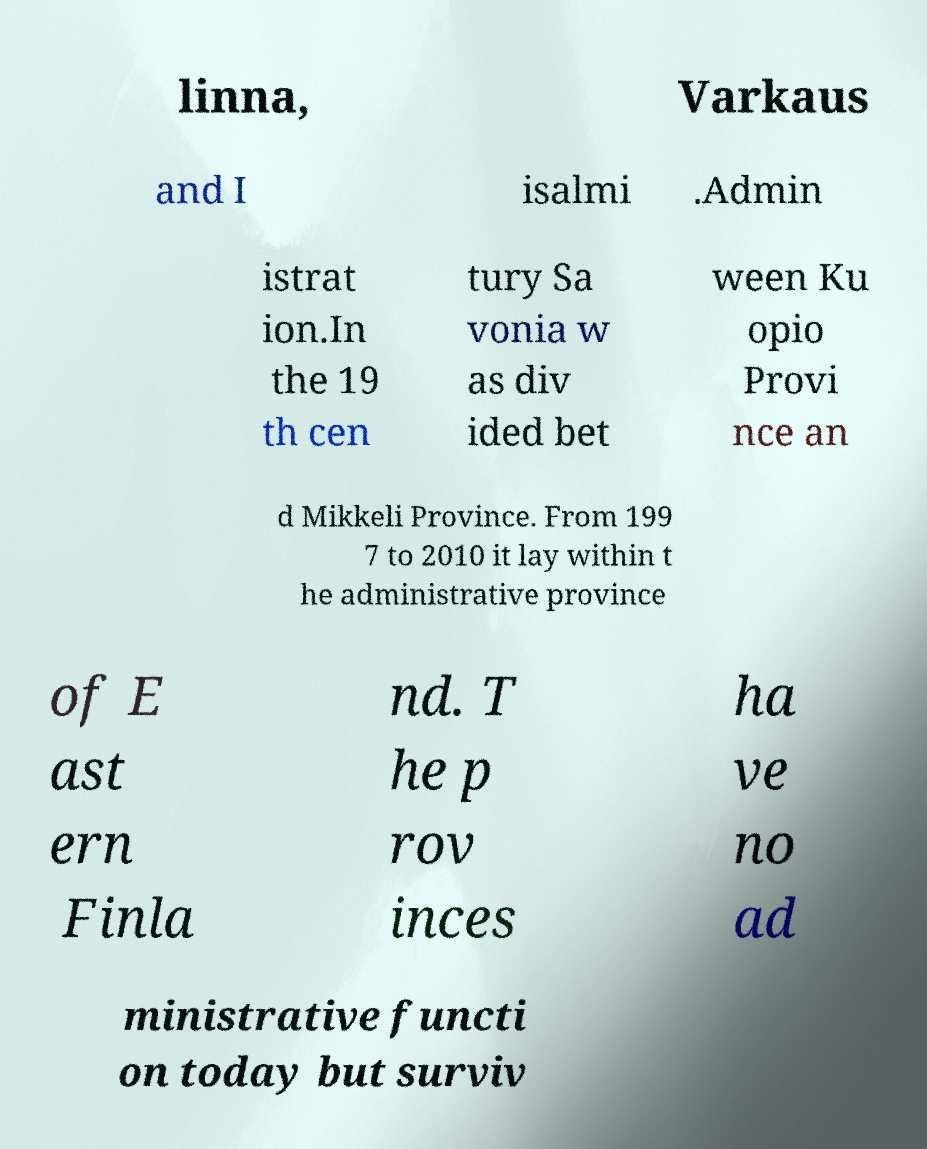Can you accurately transcribe the text from the provided image for me? linna, Varkaus and I isalmi .Admin istrat ion.In the 19 th cen tury Sa vonia w as div ided bet ween Ku opio Provi nce an d Mikkeli Province. From 199 7 to 2010 it lay within t he administrative province of E ast ern Finla nd. T he p rov inces ha ve no ad ministrative functi on today but surviv 